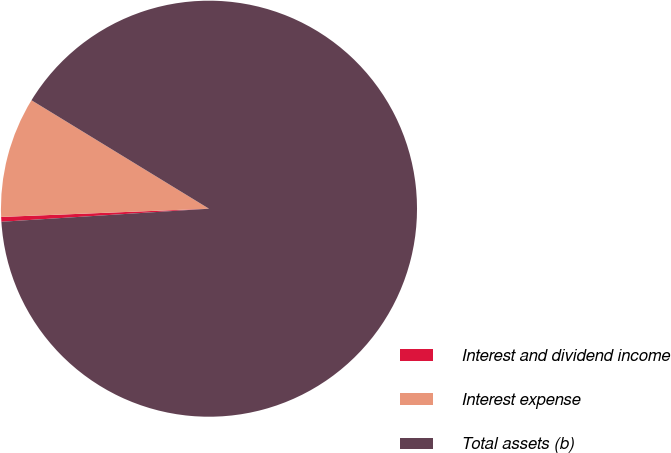Convert chart to OTSL. <chart><loc_0><loc_0><loc_500><loc_500><pie_chart><fcel>Interest and dividend income<fcel>Interest expense<fcel>Total assets (b)<nl><fcel>0.37%<fcel>9.36%<fcel>90.27%<nl></chart> 